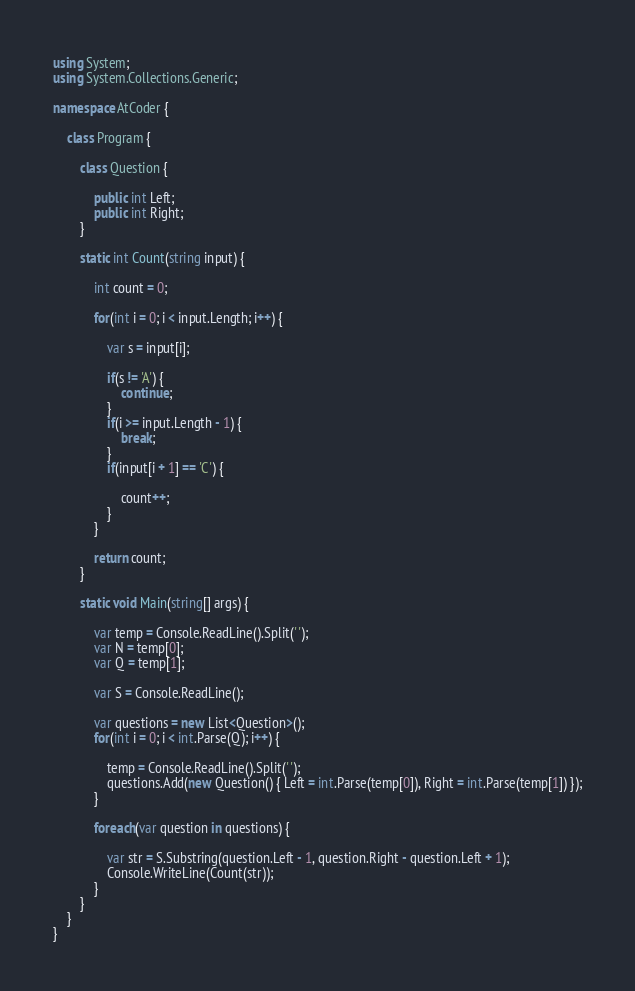Convert code to text. <code><loc_0><loc_0><loc_500><loc_500><_C#_>using System;
using System.Collections.Generic;

namespace AtCoder {

    class Program {

        class Question {

            public int Left;
            public int Right;
        }

        static int Count(string input) {

            int count = 0;

            for(int i = 0; i < input.Length; i++) {

                var s = input[i];

                if(s != 'A') {
                    continue;
                }
                if(i >= input.Length - 1) {
                    break;
                }
                if(input[i + 1] == 'C') {

                    count++;
                }
            }

            return count;
        }

        static void Main(string[] args) {

            var temp = Console.ReadLine().Split(' ');
            var N = temp[0];
            var Q = temp[1];

            var S = Console.ReadLine();

            var questions = new List<Question>();
            for(int i = 0; i < int.Parse(Q); i++) {

                temp = Console.ReadLine().Split(' ');
                questions.Add(new Question() { Left = int.Parse(temp[0]), Right = int.Parse(temp[1]) });
            }

            foreach(var question in questions) {

                var str = S.Substring(question.Left - 1, question.Right - question.Left + 1);
                Console.WriteLine(Count(str));
            }
        }
    }
}
</code> 